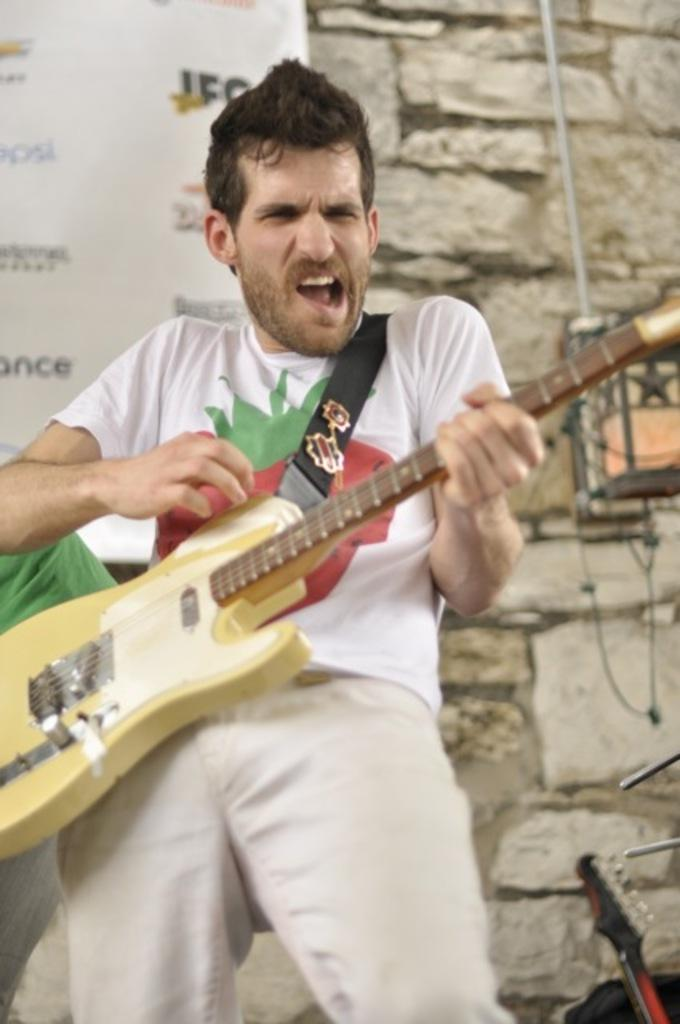What is the man in the image doing? The man is playing a guitar in the image. What else can be seen in the image besides the man? There is a hoarding and a wall in the background of the image. How many musical instruments are visible in the image? There are at least two musical instruments in the image. What is the man's profit from playing the guitar in the image? There is no information about the man's profit in the image, as it only shows him playing the guitar. Can you see a patch on the man's clothing in the image? There is no mention of a patch on the man's clothing in the provided facts, so it cannot be determined from the image. 